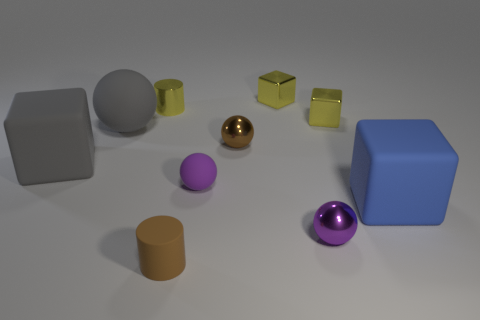What size is the matte cube that is to the right of the small yellow metal thing on the right side of the yellow block that is behind the tiny yellow metal cylinder?
Offer a very short reply. Large. There is a brown matte thing that is the same size as the purple metallic object; what is its shape?
Provide a succinct answer. Cylinder. The blue rubber thing is what shape?
Provide a succinct answer. Cube. Do the tiny thing on the left side of the brown rubber cylinder and the small brown ball have the same material?
Your response must be concise. Yes. How big is the yellow thing that is to the left of the brown object that is on the left side of the brown shiny ball?
Offer a terse response. Small. What color is the ball that is behind the blue cube and in front of the big gray block?
Provide a succinct answer. Purple. There is another cube that is the same size as the blue block; what is it made of?
Your response must be concise. Rubber. What number of other objects are the same material as the yellow cylinder?
Keep it short and to the point. 4. There is a large cube that is to the left of the large gray rubber sphere; does it have the same color as the matte object behind the brown metallic sphere?
Keep it short and to the point. Yes. There is a large matte thing that is right of the tiny cylinder in front of the brown ball; what is its shape?
Make the answer very short. Cube. 